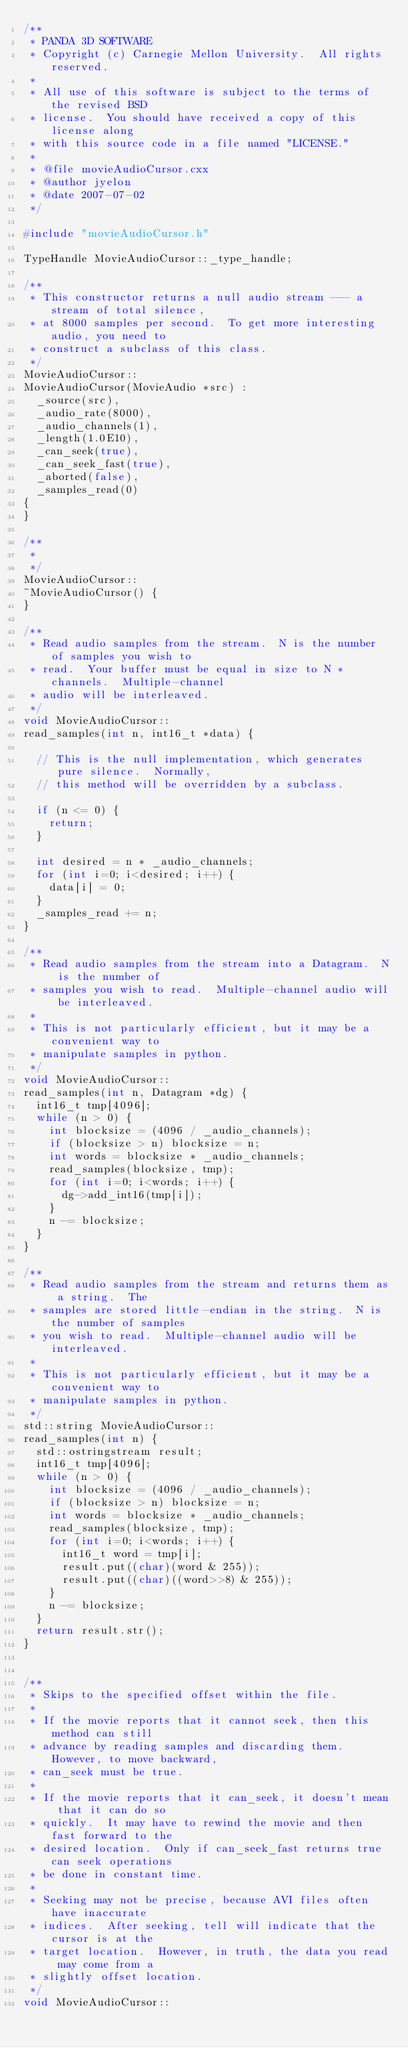<code> <loc_0><loc_0><loc_500><loc_500><_C++_>/**
 * PANDA 3D SOFTWARE
 * Copyright (c) Carnegie Mellon University.  All rights reserved.
 *
 * All use of this software is subject to the terms of the revised BSD
 * license.  You should have received a copy of this license along
 * with this source code in a file named "LICENSE."
 *
 * @file movieAudioCursor.cxx
 * @author jyelon
 * @date 2007-07-02
 */

#include "movieAudioCursor.h"

TypeHandle MovieAudioCursor::_type_handle;

/**
 * This constructor returns a null audio stream --- a stream of total silence,
 * at 8000 samples per second.  To get more interesting audio, you need to
 * construct a subclass of this class.
 */
MovieAudioCursor::
MovieAudioCursor(MovieAudio *src) :
  _source(src),
  _audio_rate(8000),
  _audio_channels(1),
  _length(1.0E10),
  _can_seek(true),
  _can_seek_fast(true),
  _aborted(false),
  _samples_read(0)
{
}

/**
 *
 */
MovieAudioCursor::
~MovieAudioCursor() {
}

/**
 * Read audio samples from the stream.  N is the number of samples you wish to
 * read.  Your buffer must be equal in size to N * channels.  Multiple-channel
 * audio will be interleaved.
 */
void MovieAudioCursor::
read_samples(int n, int16_t *data) {

  // This is the null implementation, which generates pure silence.  Normally,
  // this method will be overridden by a subclass.

  if (n <= 0) {
    return;
  }

  int desired = n * _audio_channels;
  for (int i=0; i<desired; i++) {
    data[i] = 0;
  }
  _samples_read += n;
}

/**
 * Read audio samples from the stream into a Datagram.  N is the number of
 * samples you wish to read.  Multiple-channel audio will be interleaved.
 *
 * This is not particularly efficient, but it may be a convenient way to
 * manipulate samples in python.
 */
void MovieAudioCursor::
read_samples(int n, Datagram *dg) {
  int16_t tmp[4096];
  while (n > 0) {
    int blocksize = (4096 / _audio_channels);
    if (blocksize > n) blocksize = n;
    int words = blocksize * _audio_channels;
    read_samples(blocksize, tmp);
    for (int i=0; i<words; i++) {
      dg->add_int16(tmp[i]);
    }
    n -= blocksize;
  }
}

/**
 * Read audio samples from the stream and returns them as a string.  The
 * samples are stored little-endian in the string.  N is the number of samples
 * you wish to read.  Multiple-channel audio will be interleaved.
 *
 * This is not particularly efficient, but it may be a convenient way to
 * manipulate samples in python.
 */
std::string MovieAudioCursor::
read_samples(int n) {
  std::ostringstream result;
  int16_t tmp[4096];
  while (n > 0) {
    int blocksize = (4096 / _audio_channels);
    if (blocksize > n) blocksize = n;
    int words = blocksize * _audio_channels;
    read_samples(blocksize, tmp);
    for (int i=0; i<words; i++) {
      int16_t word = tmp[i];
      result.put((char)(word & 255));
      result.put((char)((word>>8) & 255));
    }
    n -= blocksize;
  }
  return result.str();
}


/**
 * Skips to the specified offset within the file.
 *
 * If the movie reports that it cannot seek, then this method can still
 * advance by reading samples and discarding them.  However, to move backward,
 * can_seek must be true.
 *
 * If the movie reports that it can_seek, it doesn't mean that it can do so
 * quickly.  It may have to rewind the movie and then fast forward to the
 * desired location.  Only if can_seek_fast returns true can seek operations
 * be done in constant time.
 *
 * Seeking may not be precise, because AVI files often have inaccurate
 * indices.  After seeking, tell will indicate that the cursor is at the
 * target location.  However, in truth, the data you read may come from a
 * slightly offset location.
 */
void MovieAudioCursor::</code> 